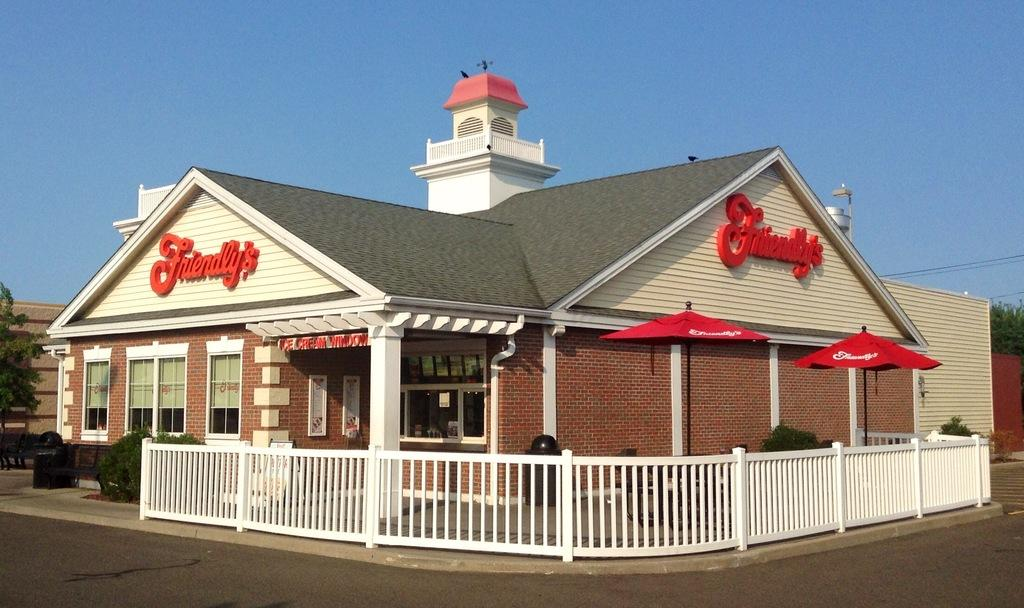<image>
Describe the image concisely. A restaurant named Friendlys along side another building. 